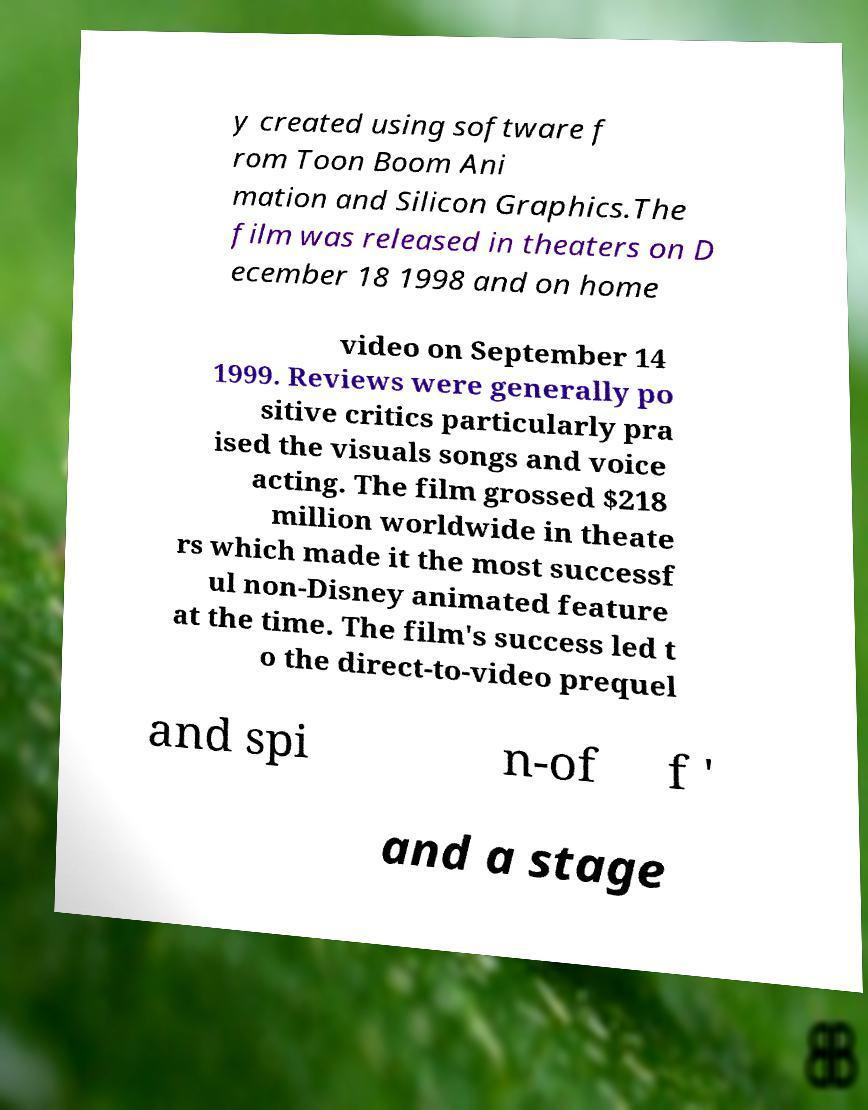There's text embedded in this image that I need extracted. Can you transcribe it verbatim? y created using software f rom Toon Boom Ani mation and Silicon Graphics.The film was released in theaters on D ecember 18 1998 and on home video on September 14 1999. Reviews were generally po sitive critics particularly pra ised the visuals songs and voice acting. The film grossed $218 million worldwide in theate rs which made it the most successf ul non-Disney animated feature at the time. The film's success led t o the direct-to-video prequel and spi n-of f ' and a stage 